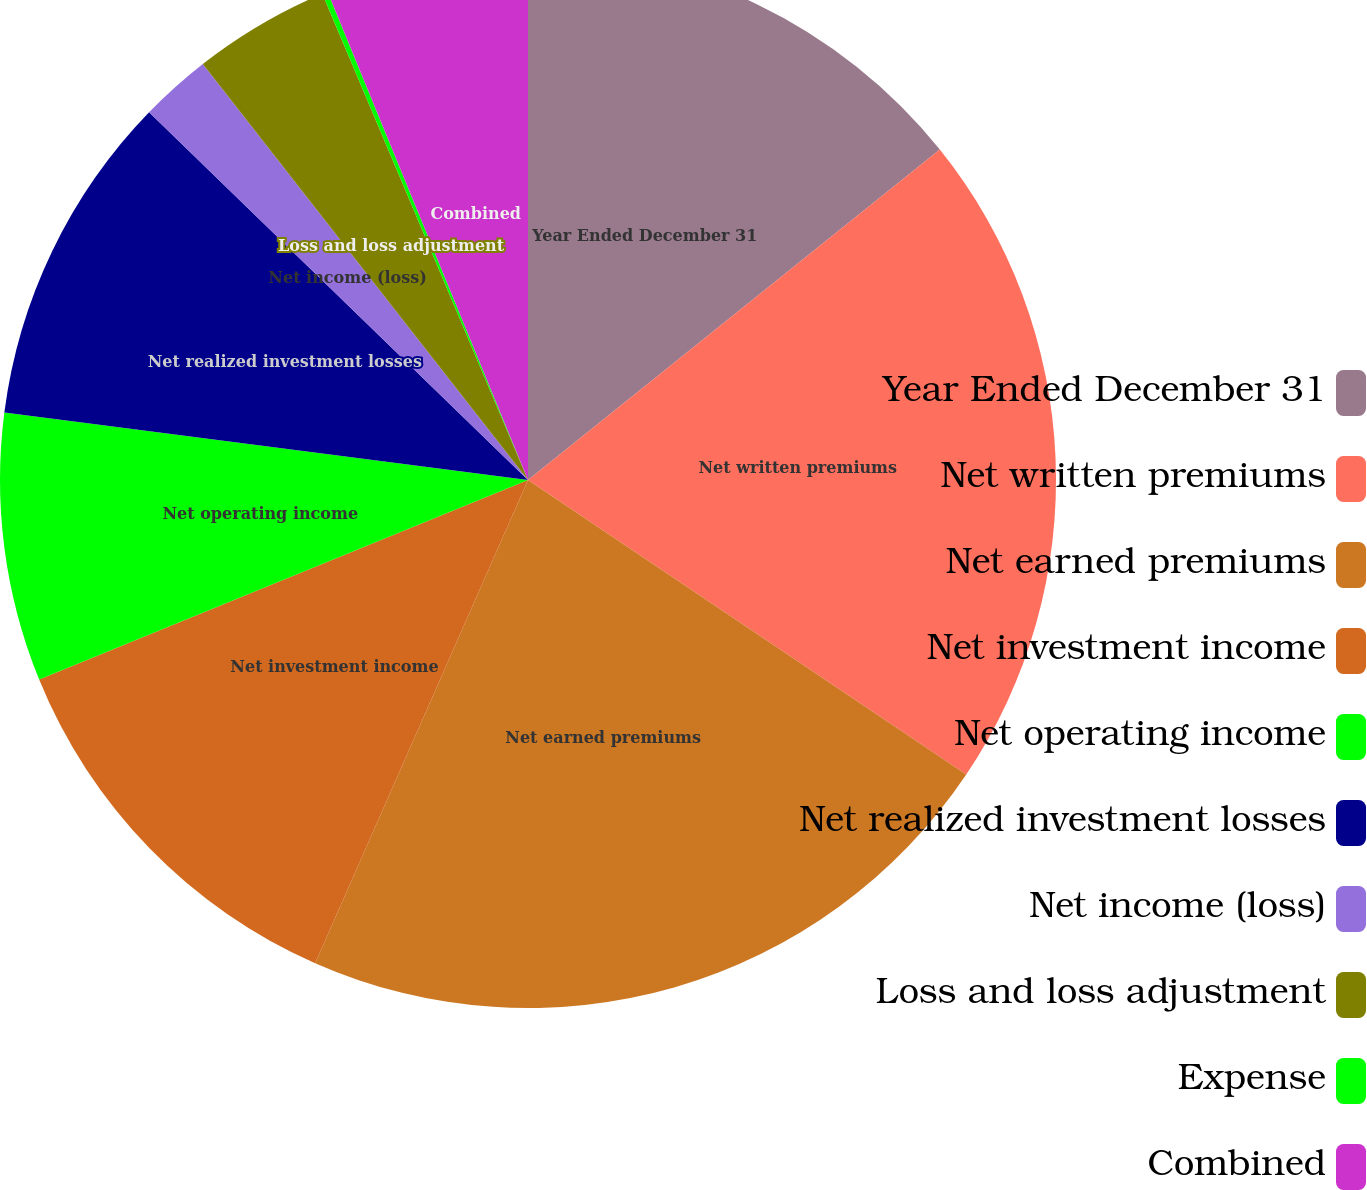Convert chart to OTSL. <chart><loc_0><loc_0><loc_500><loc_500><pie_chart><fcel>Year Ended December 31<fcel>Net written premiums<fcel>Net earned premiums<fcel>Net investment income<fcel>Net operating income<fcel>Net realized investment losses<fcel>Net income (loss)<fcel>Loss and loss adjustment<fcel>Expense<fcel>Combined<nl><fcel>14.24%<fcel>20.18%<fcel>22.19%<fcel>12.23%<fcel>8.21%<fcel>10.22%<fcel>2.18%<fcel>4.19%<fcel>0.17%<fcel>6.2%<nl></chart> 